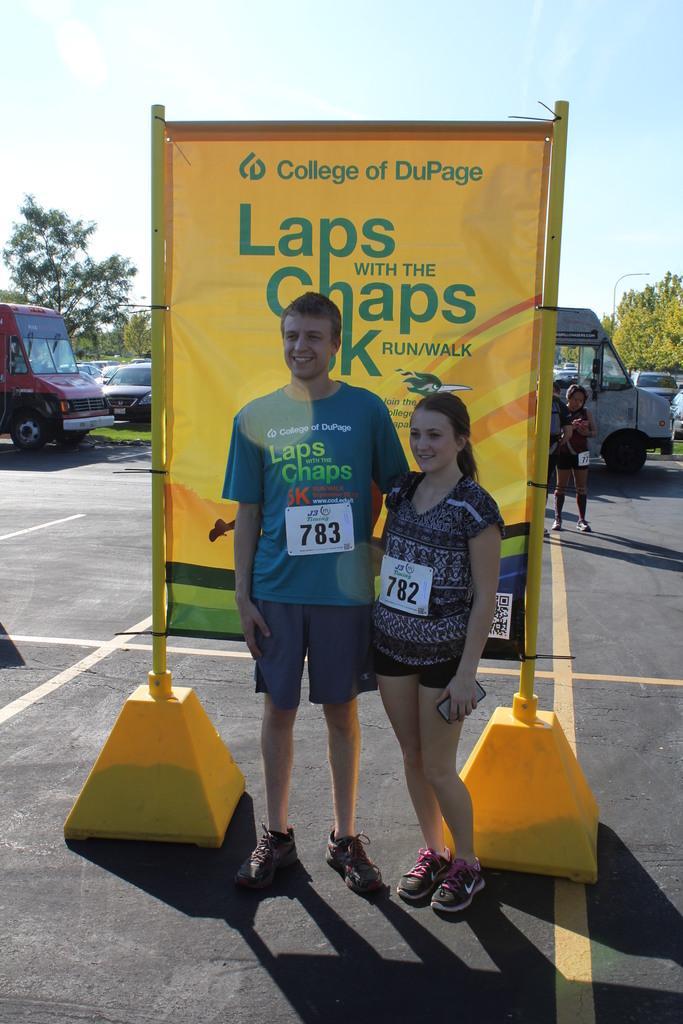Describe this image in one or two sentences. Here we can see a man and a woman posing to a camera and they are smiling. Here we can see vehicles, trees, banner, and a person. In the background there is sky. 